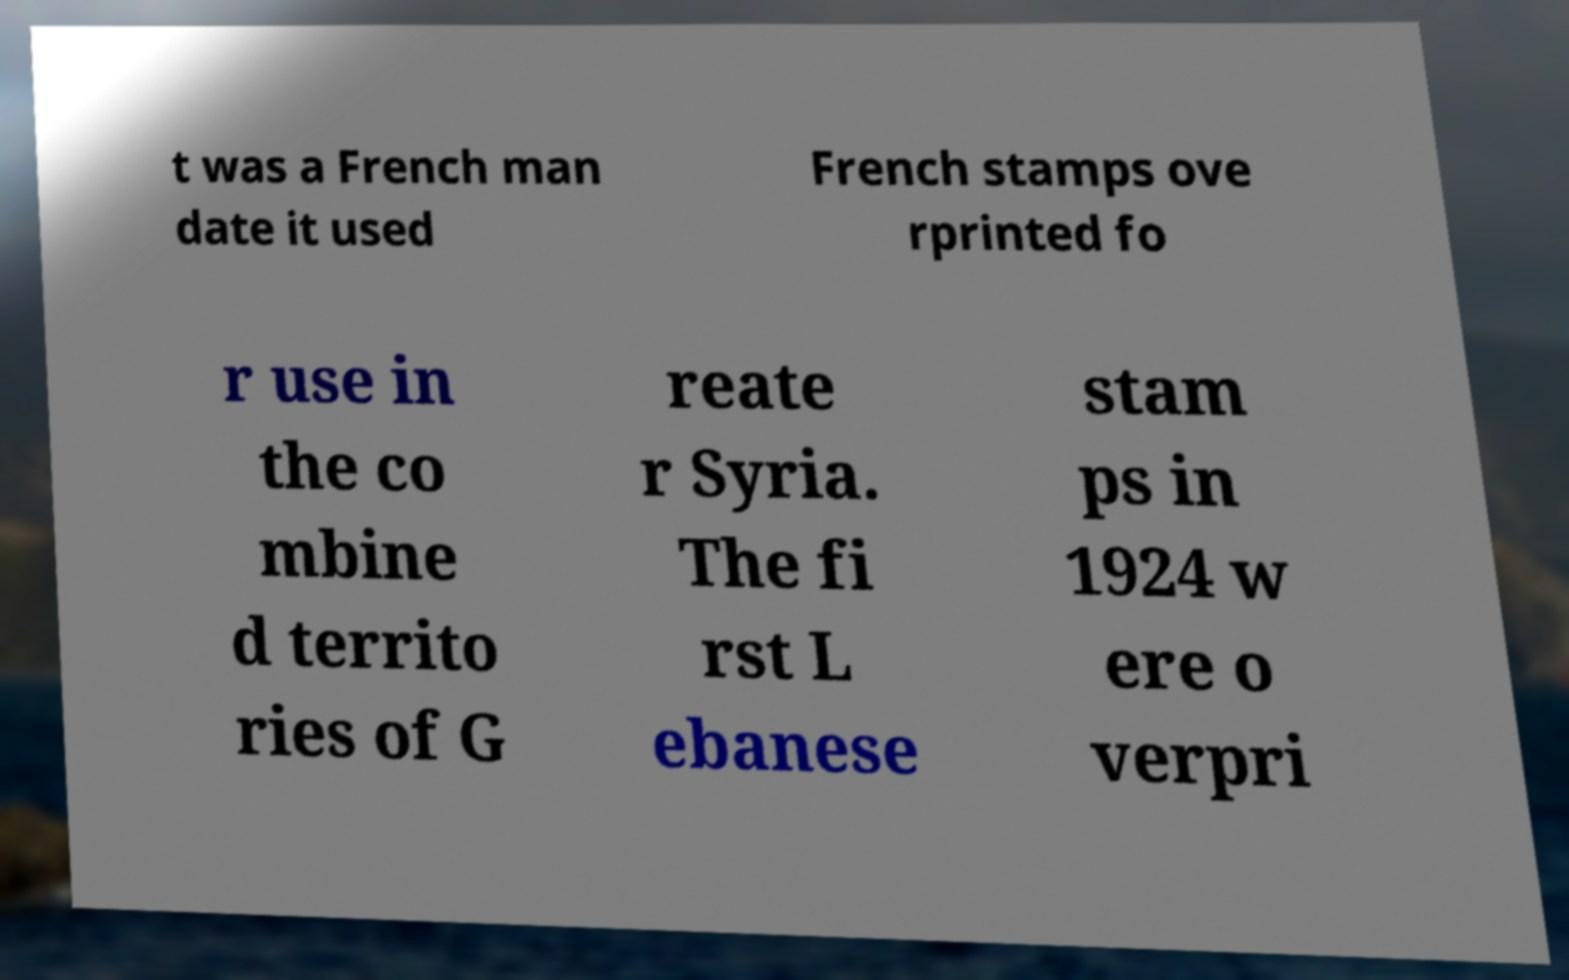Please identify and transcribe the text found in this image. t was a French man date it used French stamps ove rprinted fo r use in the co mbine d territo ries of G reate r Syria. The fi rst L ebanese stam ps in 1924 w ere o verpri 